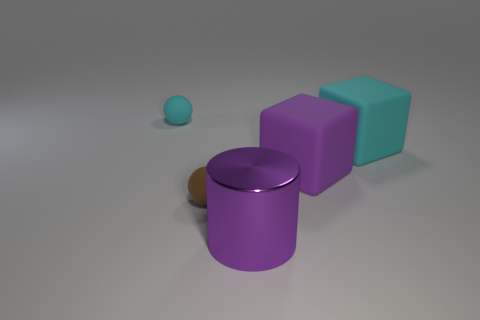Subtract all blue blocks. Subtract all yellow balls. How many blocks are left? 2 Add 5 small green cylinders. How many objects exist? 10 Subtract all cylinders. How many objects are left? 4 Subtract all brown matte spheres. Subtract all brown things. How many objects are left? 3 Add 2 large cyan matte blocks. How many large cyan matte blocks are left? 3 Add 4 purple shiny cylinders. How many purple shiny cylinders exist? 5 Subtract 1 brown spheres. How many objects are left? 4 